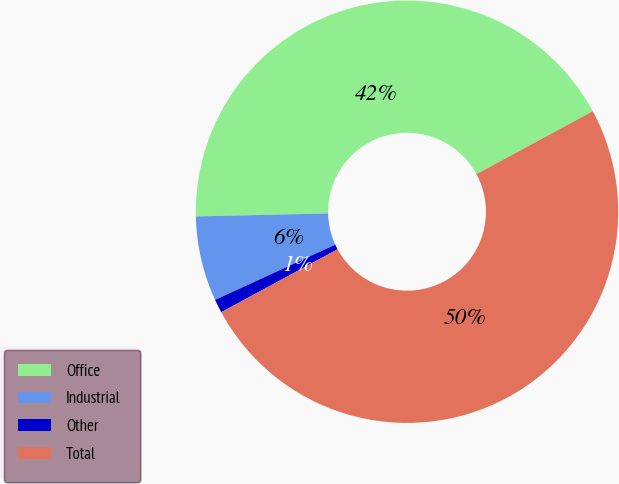<chart> <loc_0><loc_0><loc_500><loc_500><pie_chart><fcel>Office<fcel>Industrial<fcel>Other<fcel>Total<nl><fcel>42.46%<fcel>6.5%<fcel>1.04%<fcel>50.0%<nl></chart> 